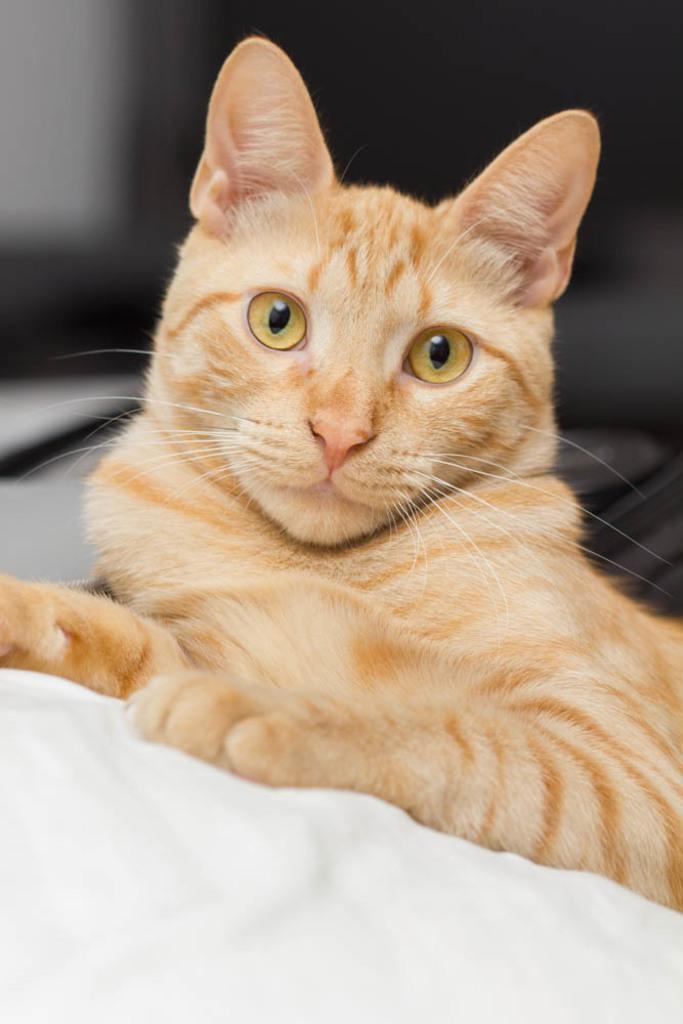Could you give a brief overview of what you see in this image? In the center of the image, we can see a cat on the cloth. 